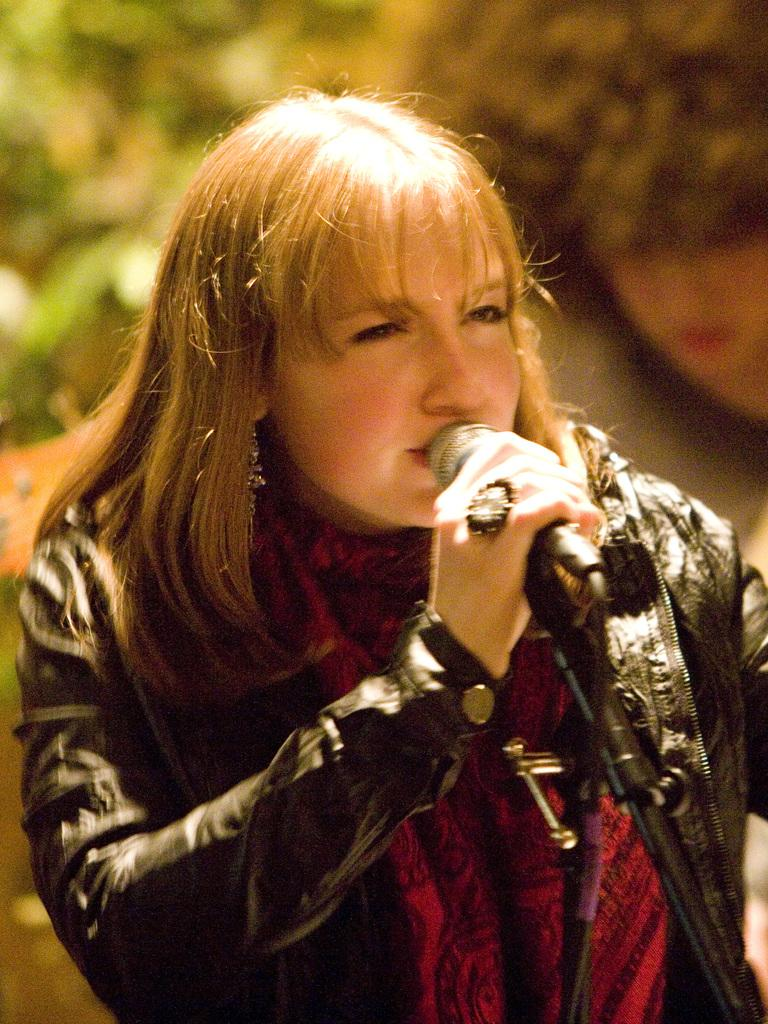Who is the main subject in the image? There is a woman in the image. What is the woman doing in the image? The woman is singing. What is the woman holding in the image? The woman is holding a microphone. What is the woman wearing in the image? The woman is wearing a black jacket and a red dress. What can be seen in the background of the image? There are plants visible in the background of the image. What type of things does the woman's mom collect in the image? There is no mention of the woman's mom or any collections in the image. 